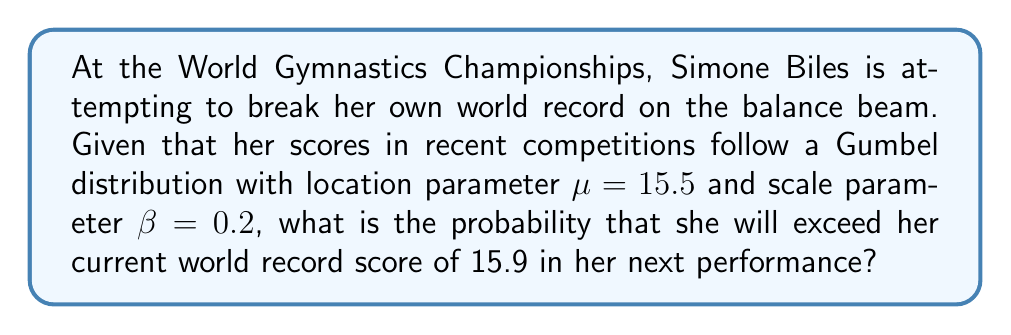Show me your answer to this math problem. Let's approach this step-by-step using extreme value theory and the Gumbel distribution:

1) The Gumbel distribution is a type of extreme value distribution often used to model maxima. It's appropriate here as we're dealing with record-breaking performances.

2) The cumulative distribution function (CDF) of the Gumbel distribution is:

   $$F(x) = e^{-e^{-(x-\mu)/\beta}}$$

3) We want the probability of exceeding 15.9, which is the complement of the CDF:

   $$P(X > 15.9) = 1 - P(X \leq 15.9) = 1 - F(15.9)$$

4) Substituting the given values ($\mu = 15.5$, $\beta = 0.2$, $x = 15.9$) into the CDF:

   $$F(15.9) = e^{-e^{-(15.9-15.5)/0.2}}$$

5) Simplifying:
   
   $$F(15.9) = e^{-e^{-2}} \approx 0.8746$$

6) Therefore, the probability of exceeding 15.9 is:

   $$P(X > 15.9) = 1 - 0.8746 \approx 0.1254$$

7) Converting to a percentage:

   $$0.1254 \times 100\% \approx 12.54\%$$
Answer: 12.54% 